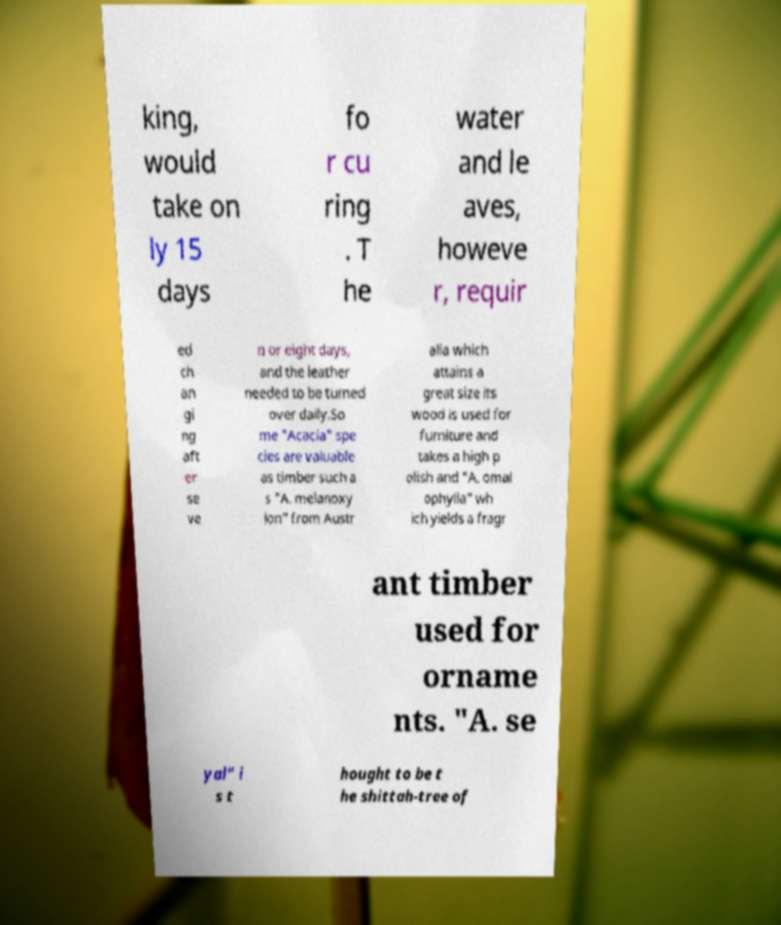I need the written content from this picture converted into text. Can you do that? king, would take on ly 15 days fo r cu ring . T he water and le aves, howeve r, requir ed ch an gi ng aft er se ve n or eight days, and the leather needed to be turned over daily.So me "Acacia" spe cies are valuable as timber such a s "A. melanoxy lon" from Austr alia which attains a great size its wood is used for furniture and takes a high p olish and "A. omal ophylla" wh ich yields a fragr ant timber used for orname nts. "A. se yal" i s t hought to be t he shittah-tree of 